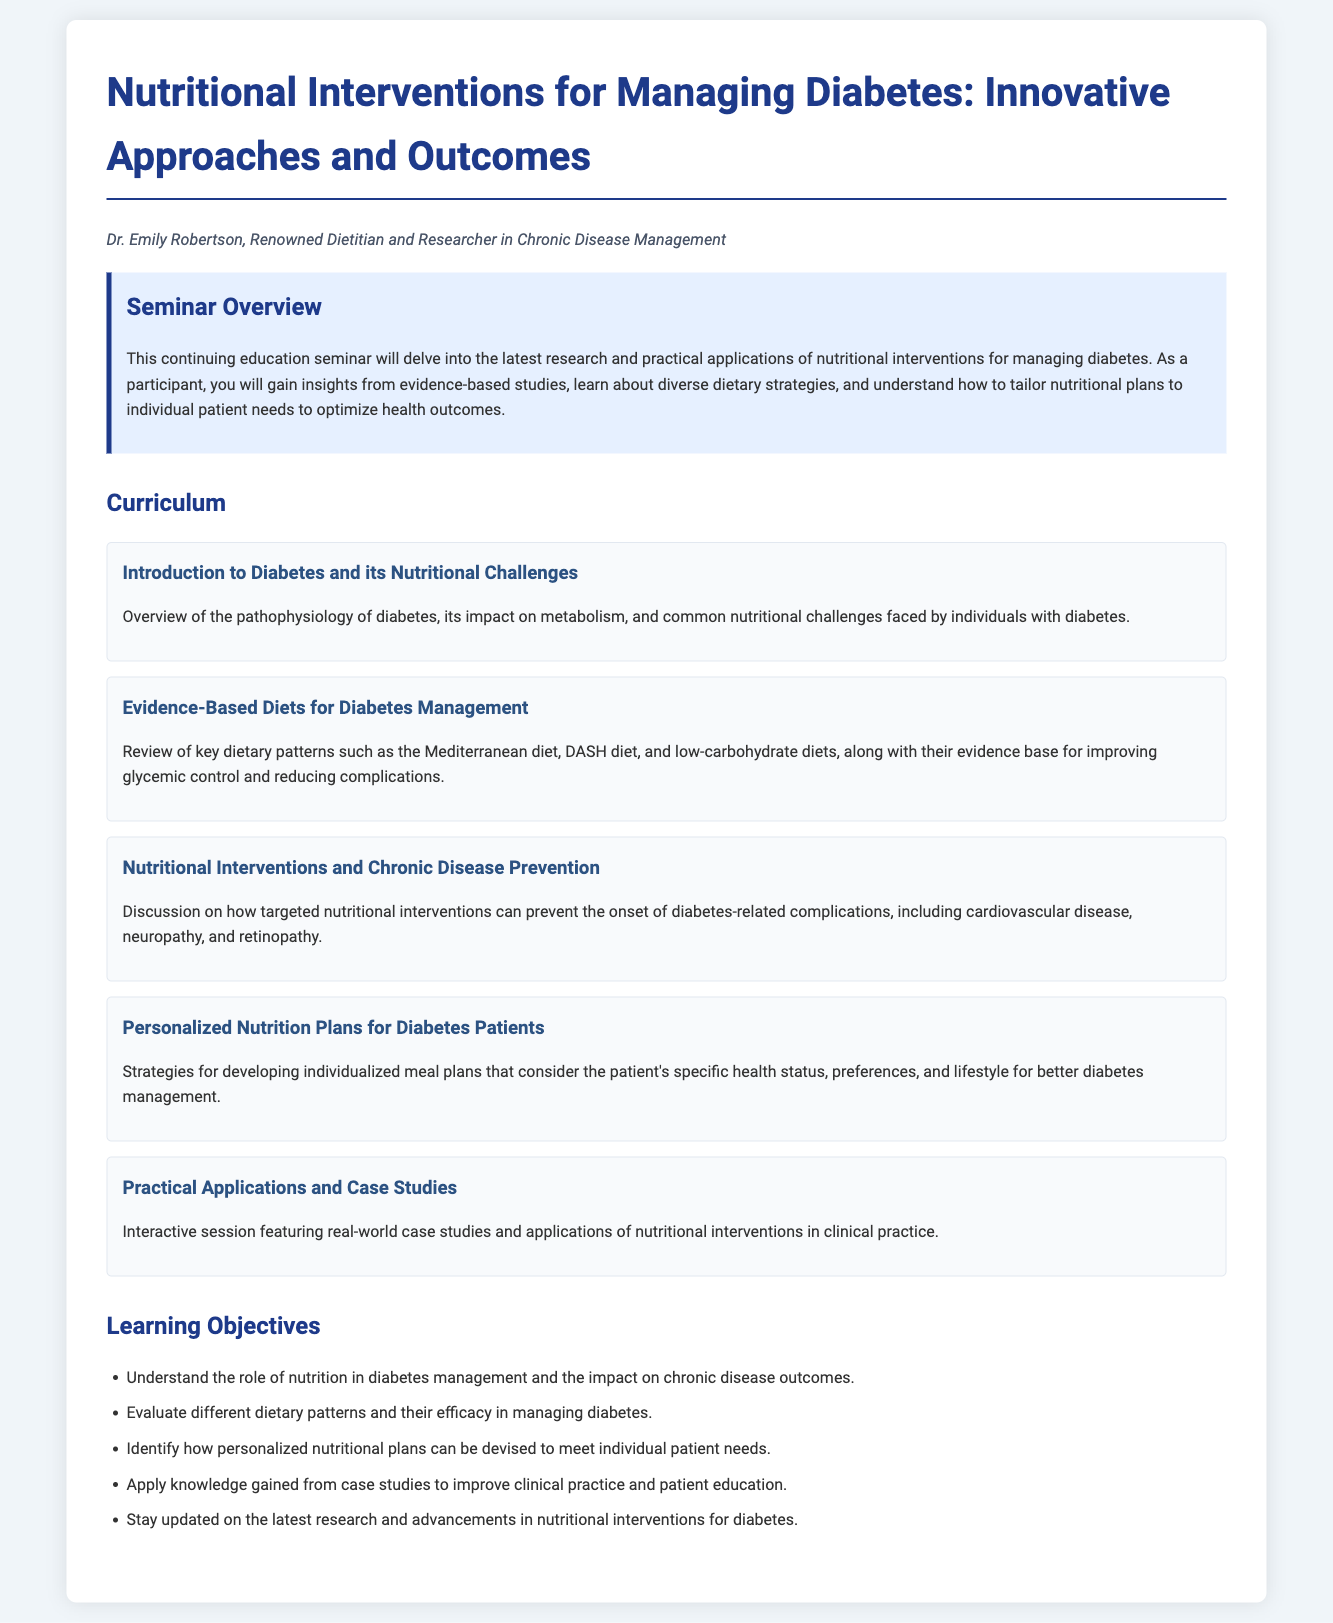what is the title of the seminar? The title is the main heading of the document, capturing the focus of the seminar.
Answer: Nutritional Interventions for Managing Diabetes: Innovative Approaches and Outcomes who is the author of the seminar? The author is specified at the beginning of the document, indicating the expert leading the seminar.
Answer: Dr. Emily Robertson how many modules are included in the curriculum? The modules listed in the curriculum section provide the structure of the seminar's content.
Answer: five what is one evidence-based diet discussed for diabetes management? This refers to specific dietary patterns mentioned in the curriculum that have been supported by research.
Answer: Mediterranean diet what is one objective of the seminar? The objectives listed outline what participants are expected to learn during the seminar.
Answer: Understand the role of nutrition in diabetes management and the impact on chronic disease outcomes which module focuses on individualized meal plans? This is a specific inquiry about the curriculum, referencing a module that addresses tailoring nutrition.
Answer: Personalized Nutrition Plans for Diabetes Patients what type of session is included in the curriculum? This question pertains to the format of learning included in the seminar, highlighting interactivity.
Answer: Interactive session how does the seminar address chronic disease prevention? This inquiry requires connecting information about the content focus of one of the modules.
Answer: Discussion on how targeted nutritional interventions can prevent the onset of diabetes-related complications 